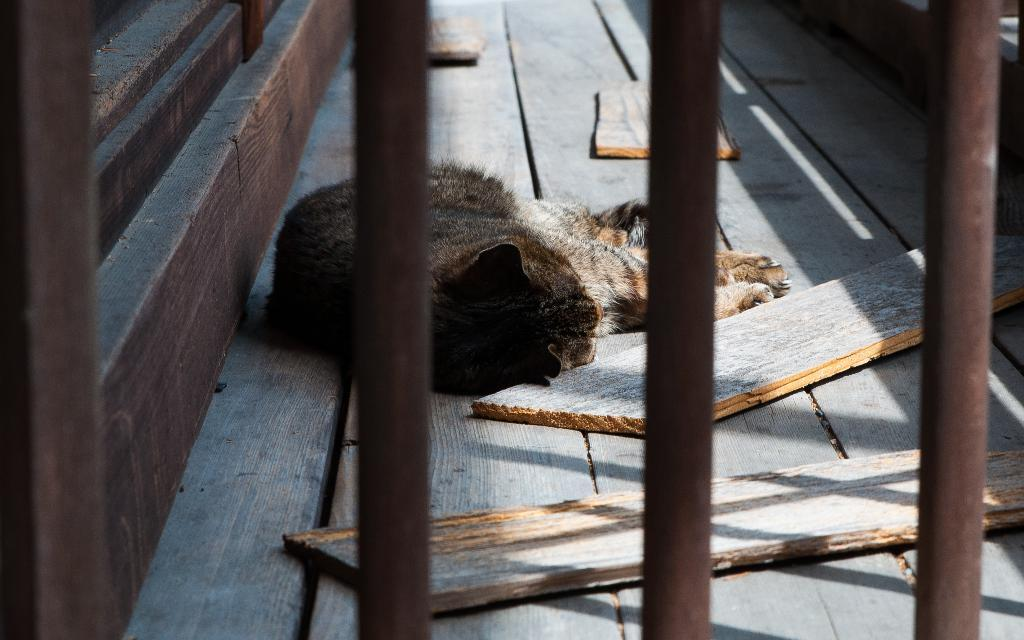What type of grill is present in the image? There is a metal rod grill in the image. What animal can be seen in the image? A cat is sleeping on a wooden surface in the image. What material is used for the sticks visible in the image? The wooden sticks in the image are made of wood. Where are the wooden sticks located in relation to the cat? The cat is beside some wooden sticks, and there is a wooden stick behind the cat. What type of parent is present in the image? There is no parent present in the image; it features a cat sleeping on a wooden surface and wooden sticks. How does the cat blow out the candles in the image? There are no candles or blowing action in the image; the cat is simply sleeping on a wooden surface. 